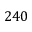Convert formula to latex. <formula><loc_0><loc_0><loc_500><loc_500>2 4 0</formula> 